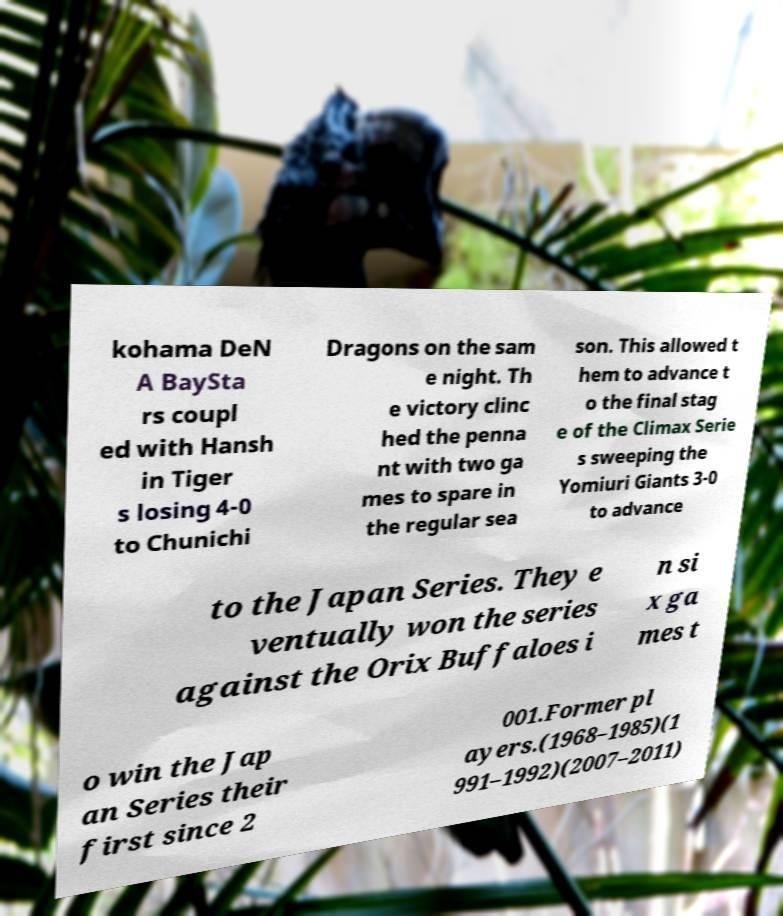Could you assist in decoding the text presented in this image and type it out clearly? kohama DeN A BaySta rs coupl ed with Hansh in Tiger s losing 4-0 to Chunichi Dragons on the sam e night. Th e victory clinc hed the penna nt with two ga mes to spare in the regular sea son. This allowed t hem to advance t o the final stag e of the Climax Serie s sweeping the Yomiuri Giants 3-0 to advance to the Japan Series. They e ventually won the series against the Orix Buffaloes i n si x ga mes t o win the Jap an Series their first since 2 001.Former pl ayers.(1968–1985)(1 991–1992)(2007–2011) 